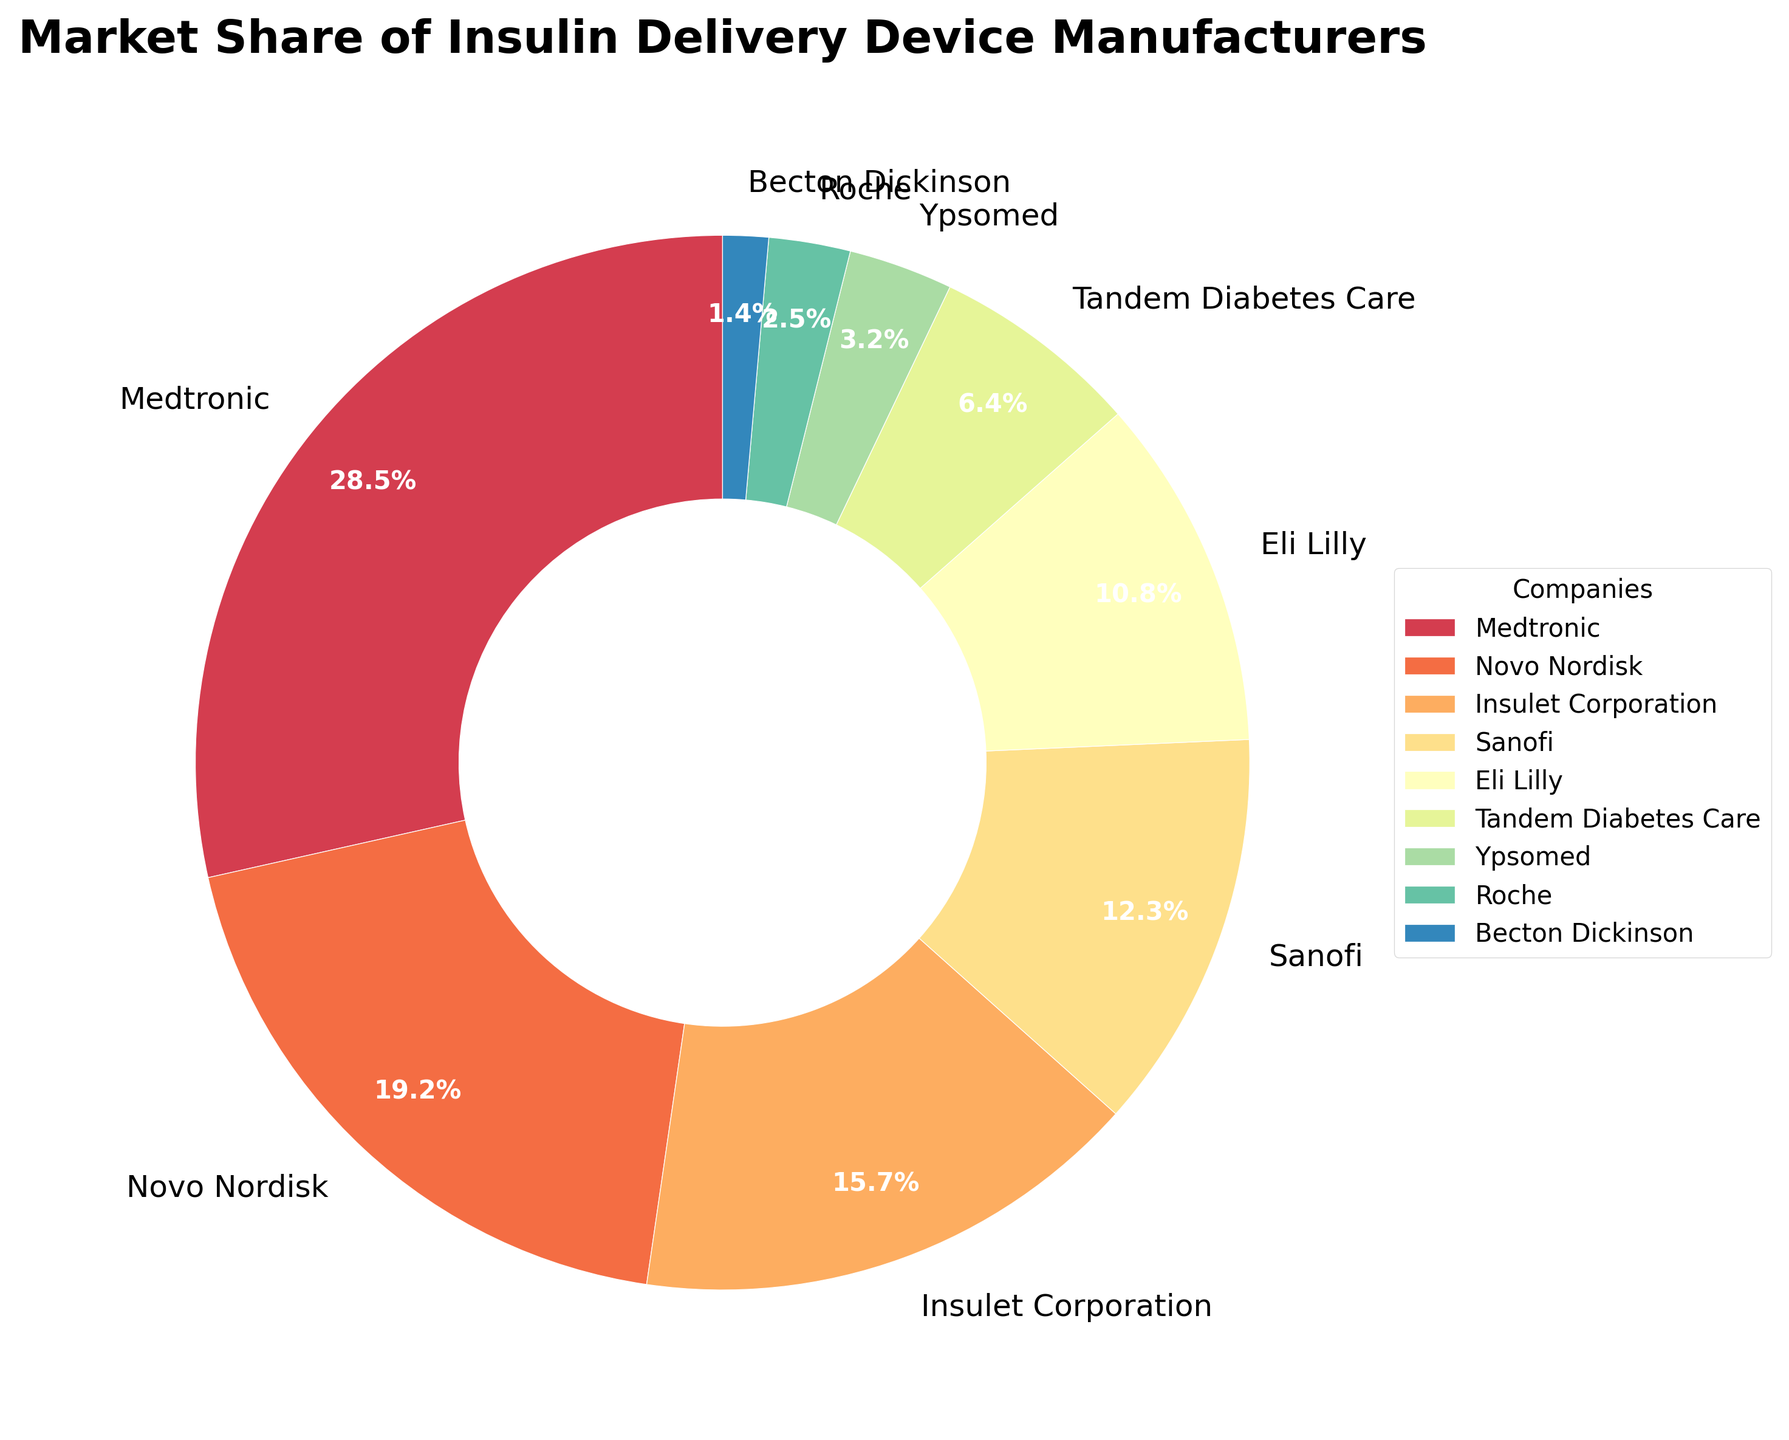What is the market share of Medtronic? The pie chart shows the market share of each company. Medtronic is labeled with 28.5%.
Answer: 28.5% Which company has the smallest market share? From the pie chart, the smallest segment belongs to Becton Dickinson, indicated by 1.4%.
Answer: Becton Dickinson Between Novo Nordisk and Insulet Corporation, which company has a higher market share, and by how much? Novo Nordisk has a higher market share (19.2%) compared to Insulet Corporation (15.7%). The difference is 19.2% - 15.7% = 3.5%.
Answer: Novo Nordisk by 3.5% Which companies have a combined market share larger than 20%? Adding individual market shares, Medtronic is 28.5%, and Novo Nordisk is (19.2%). Both are more than 20%. No others when combined.
Answer: Medtronic, Novo Nordisk What is the average market share of Sanofi, Eli Lilly, and Tandem Diabetes Care? Sum the market shares of Sanofi (12.3%), Eli Lilly (10.8%), and Tandem Diabetes Care (6.4%) and divide by 3. (12.3 + 10.8 + 6.4) / 3 = 9.8333%.
Answer: 9.8% How much larger is the market share of Medtronic compared to Roche and Ypsomed combined? Add the market shares of Roche (2.5%) and Ypsomed (3.2%) for a combined share of 5.7%, then subtract this from Medtronic's 28.5%. 28.5% - 5.7% = 22.8%.
Answer: 22.8% What is the total market share of Insulet Corporation, Sanofi, and Becton Dickinson? Sum the market shares of Insulet Corporation (15.7%), Sanofi (12.3%), and Becton Dickinson (1.4%). 15.7% + 12.3% + 1.4% = 29.4%.
Answer: 29.4% How many companies have a market share less than 10%? In the pie chart, Eli Lilly (10.8%), Tandem Diabetes Care (6.4%), Ypsomed (3.2%), Roche (2.5%), and Becton Dickinson (1.4%) make up five companies with market share less than 10%.
Answer: 5 